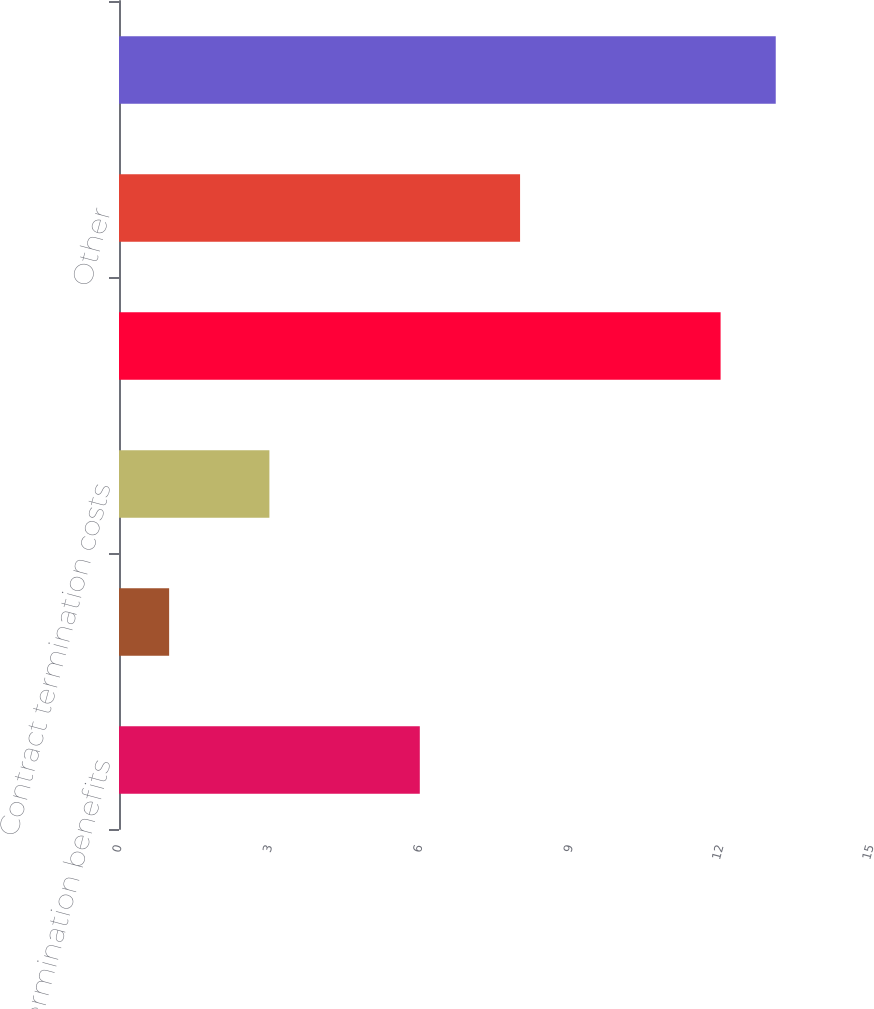Convert chart. <chart><loc_0><loc_0><loc_500><loc_500><bar_chart><fcel>Employee termination benefits<fcel>Asset impairments<fcel>Contract termination costs<fcel>Total exit costs recorded to<fcel>Other<fcel>Total plant shutdown costs<nl><fcel>6<fcel>1<fcel>3<fcel>12<fcel>8<fcel>13.1<nl></chart> 